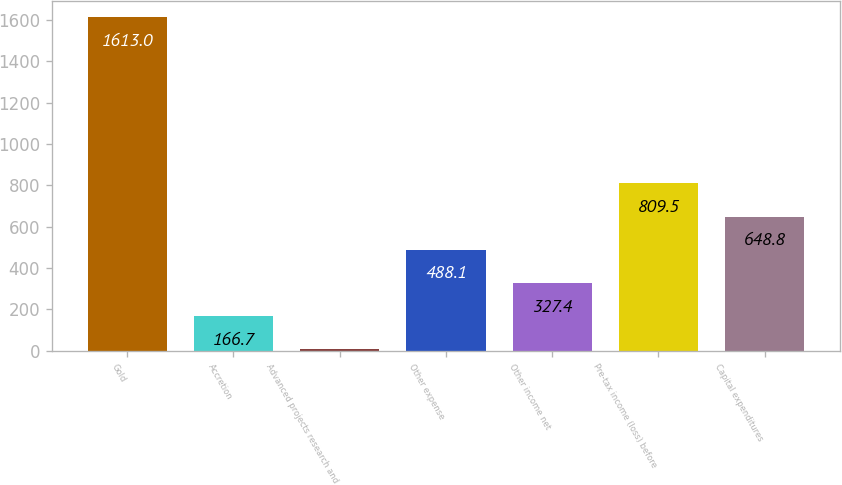Convert chart to OTSL. <chart><loc_0><loc_0><loc_500><loc_500><bar_chart><fcel>Gold<fcel>Accretion<fcel>Advanced projects research and<fcel>Other expense<fcel>Other income net<fcel>Pre-tax income (loss) before<fcel>Capital expenditures<nl><fcel>1613<fcel>166.7<fcel>6<fcel>488.1<fcel>327.4<fcel>809.5<fcel>648.8<nl></chart> 